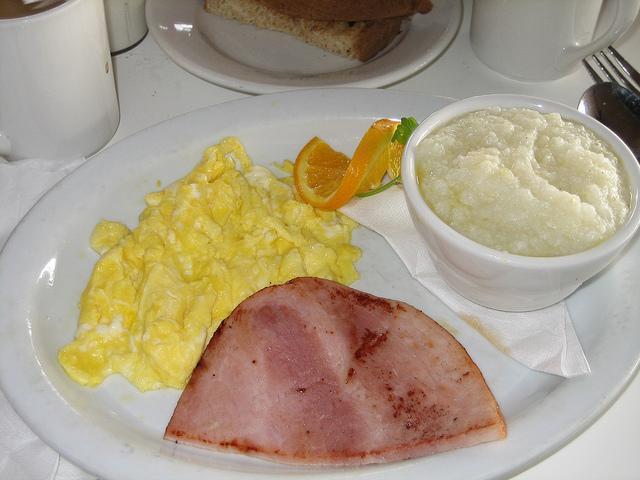How many cups are in the photo?
Give a very brief answer. 2. How many people are wearing blue?
Give a very brief answer. 0. 